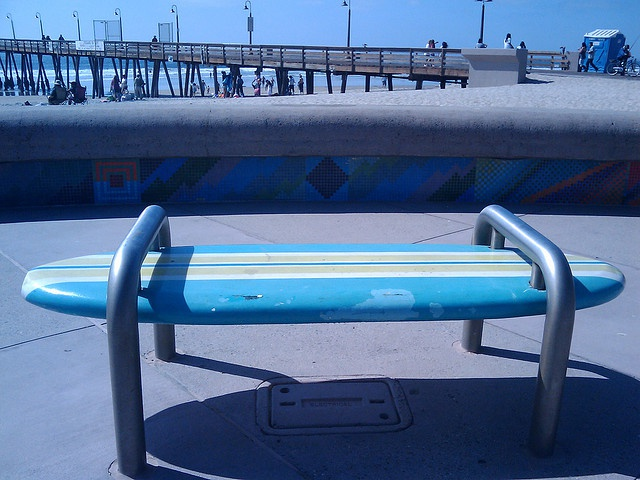Describe the objects in this image and their specific colors. I can see bench in lightblue, navy, lightgray, and darkgray tones, people in lightblue, darkgray, navy, and gray tones, bicycle in lightblue, navy, gray, and blue tones, people in lightblue, gray, navy, and blue tones, and people in lightblue, navy, darkblue, and blue tones in this image. 